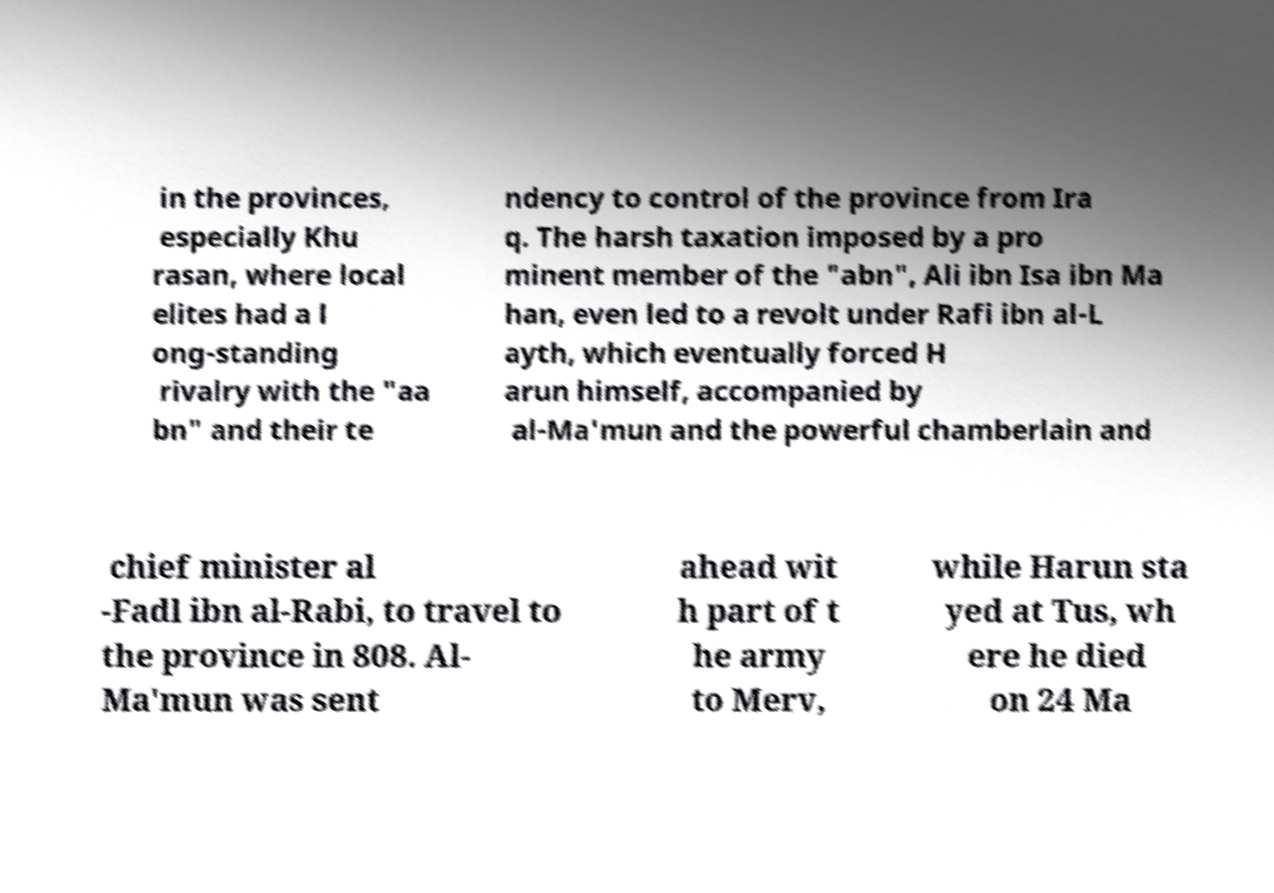For documentation purposes, I need the text within this image transcribed. Could you provide that? in the provinces, especially Khu rasan, where local elites had a l ong-standing rivalry with the "aa bn" and their te ndency to control of the province from Ira q. The harsh taxation imposed by a pro minent member of the "abn", Ali ibn Isa ibn Ma han, even led to a revolt under Rafi ibn al-L ayth, which eventually forced H arun himself, accompanied by al-Ma'mun and the powerful chamberlain and chief minister al -Fadl ibn al-Rabi, to travel to the province in 808. Al- Ma'mun was sent ahead wit h part of t he army to Merv, while Harun sta yed at Tus, wh ere he died on 24 Ma 